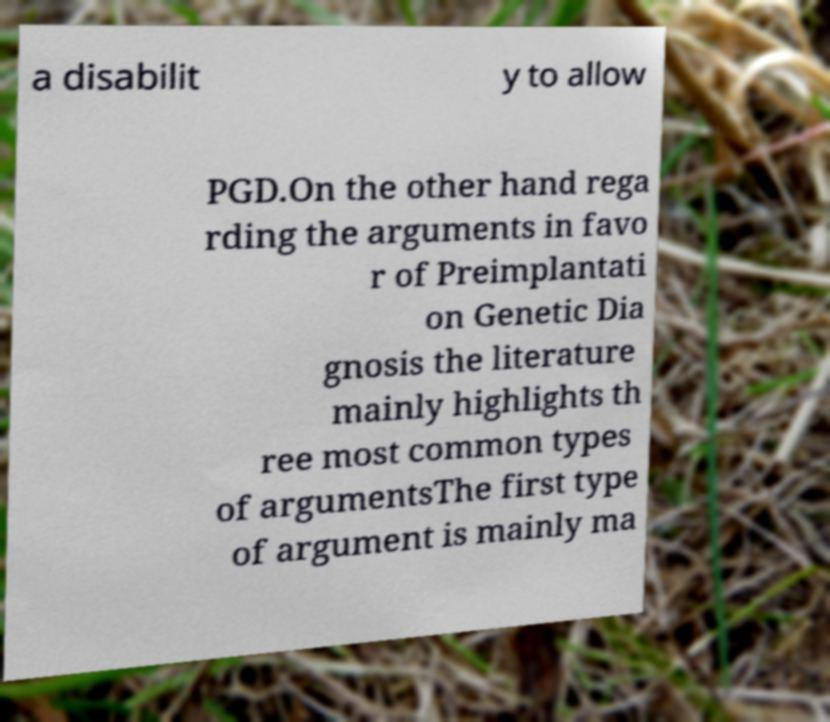Can you read and provide the text displayed in the image?This photo seems to have some interesting text. Can you extract and type it out for me? a disabilit y to allow PGD.On the other hand rega rding the arguments in favo r of Preimplantati on Genetic Dia gnosis the literature mainly highlights th ree most common types of argumentsThe first type of argument is mainly ma 